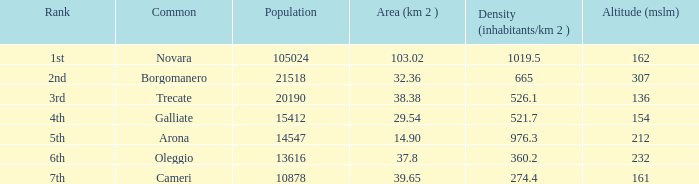What is the position of galliate common in population ranking? 4th. 